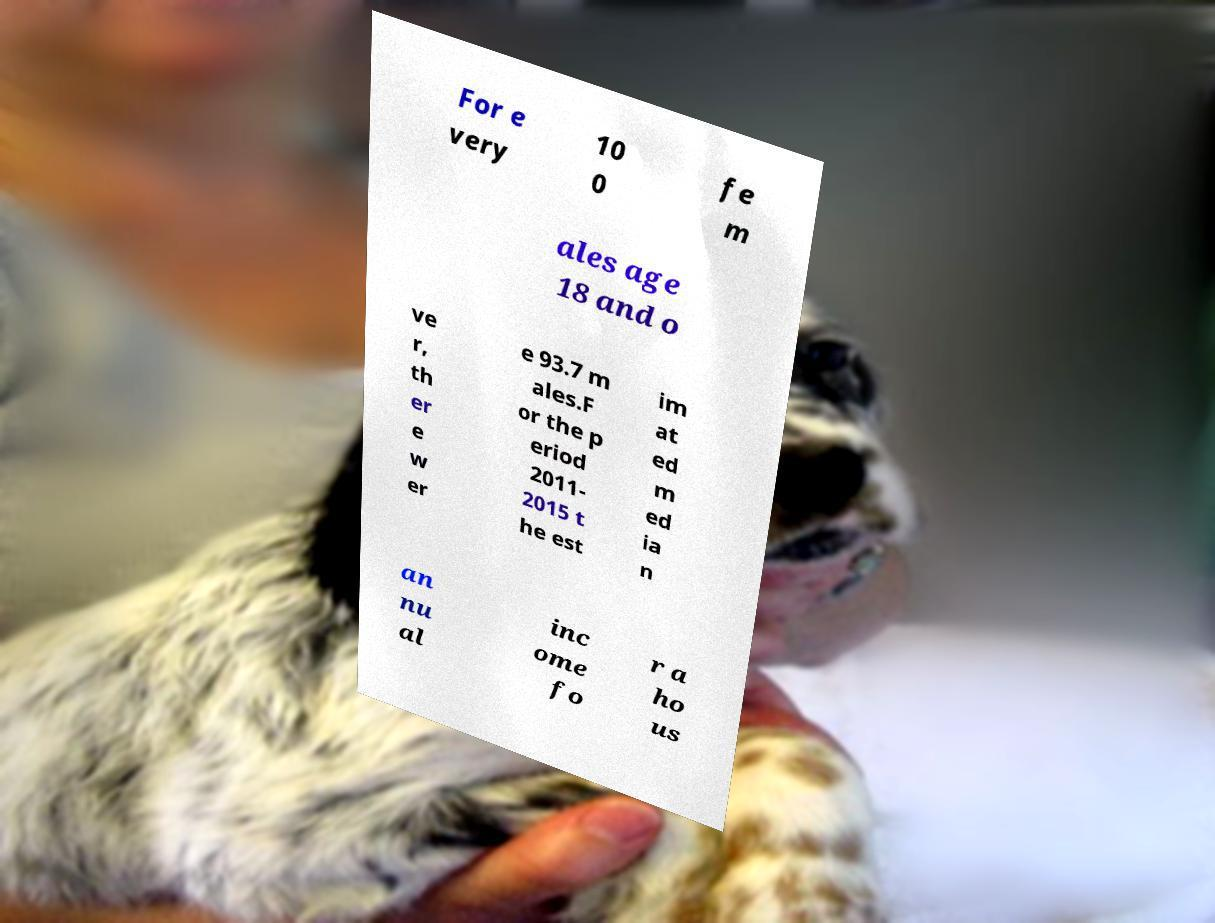What messages or text are displayed in this image? I need them in a readable, typed format. For e very 10 0 fe m ales age 18 and o ve r, th er e w er e 93.7 m ales.F or the p eriod 2011- 2015 t he est im at ed m ed ia n an nu al inc ome fo r a ho us 